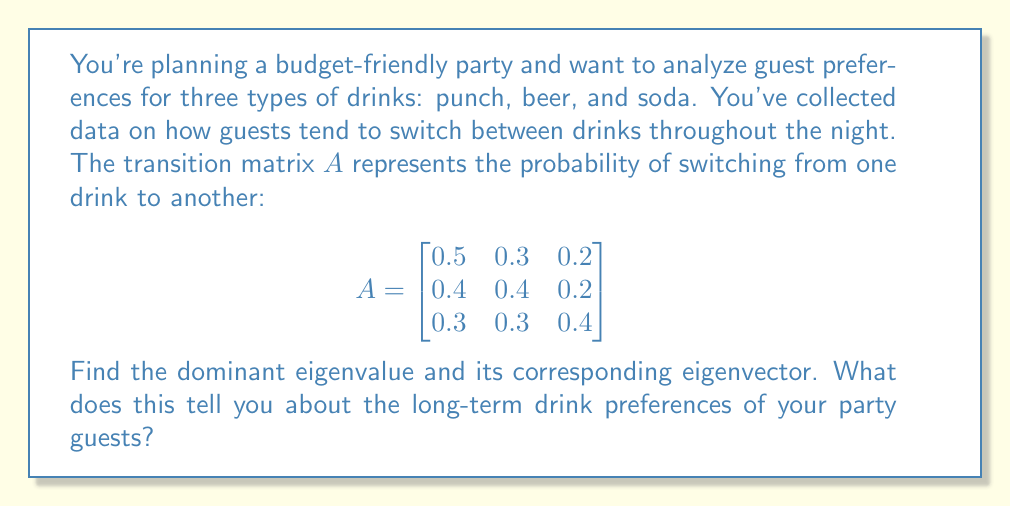Give your solution to this math problem. To find the eigenvalues and eigenvectors, we need to solve the characteristic equation:

1) First, calculate $det(A - \lambda I) = 0$:

   $$\begin{vmatrix}
   0.5-\lambda & 0.3 & 0.2 \\
   0.4 & 0.4-\lambda & 0.2 \\
   0.3 & 0.3 & 0.4-\lambda
   \end{vmatrix} = 0$$

2) Expanding this determinant:

   $(0.5-\lambda)[(0.4-\lambda)(0.4-\lambda) - 0.06] - 0.3[0.4(0.4-\lambda) - 0.06] + 0.2[0.12 - 0.3(0.4-\lambda)] = 0$

3) Simplifying:

   $-\lambda^3 + 1.3\lambda^2 - 0.17\lambda + 0 = 0$

4) The roots of this equation are the eigenvalues. The largest root (dominant eigenvalue) is $\lambda_1 = 1$.

5) To find the corresponding eigenvector $v$, solve $(A - \lambda I)v = 0$:

   $$\begin{bmatrix}
   -0.5 & 0.3 & 0.2 \\
   0.4 & -0.6 & 0.2 \\
   0.3 & 0.3 & -0.6
   \end{bmatrix} \begin{bmatrix} v_1 \\ v_2 \\ v_3 \end{bmatrix} = \begin{bmatrix} 0 \\ 0 \\ 0 \end{bmatrix}$$

6) Solving this system, we get the eigenvector $v = [10, 8, 7]^T$ (or any scalar multiple).

7) Normalizing this vector to make the components sum to 1:

   $$v_{normalized} = \frac{1}{25} [10, 8, 7]^T = [0.4, 0.32, 0.28]^T$$

The dominant eigenvalue of 1 indicates that this is a stable system. The corresponding normalized eigenvector represents the long-term distribution of drink preferences.
Answer: The dominant eigenvalue is 1, and its corresponding normalized eigenvector is [0.4, 0.32, 0.28]^T. This indicates that in the long run, approximately 40% of guests will prefer punch, 32% will prefer beer, and 28% will prefer soda, regardless of their initial drink choices. 